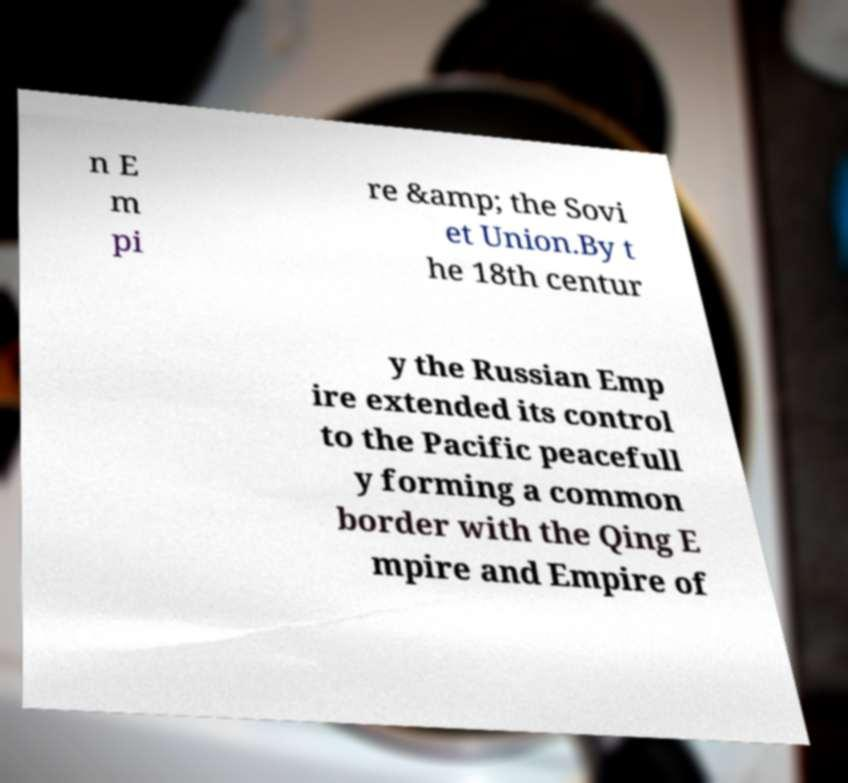Please read and relay the text visible in this image. What does it say? n E m pi re &amp; the Sovi et Union.By t he 18th centur y the Russian Emp ire extended its control to the Pacific peacefull y forming a common border with the Qing E mpire and Empire of 